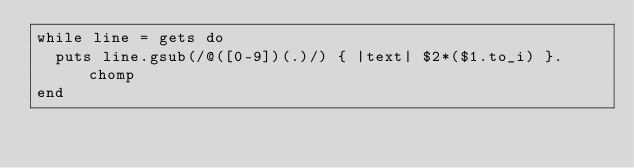Convert code to text. <code><loc_0><loc_0><loc_500><loc_500><_Ruby_>while line = gets do
  puts line.gsub(/@([0-9])(.)/) { |text| $2*($1.to_i) }.chomp
end</code> 